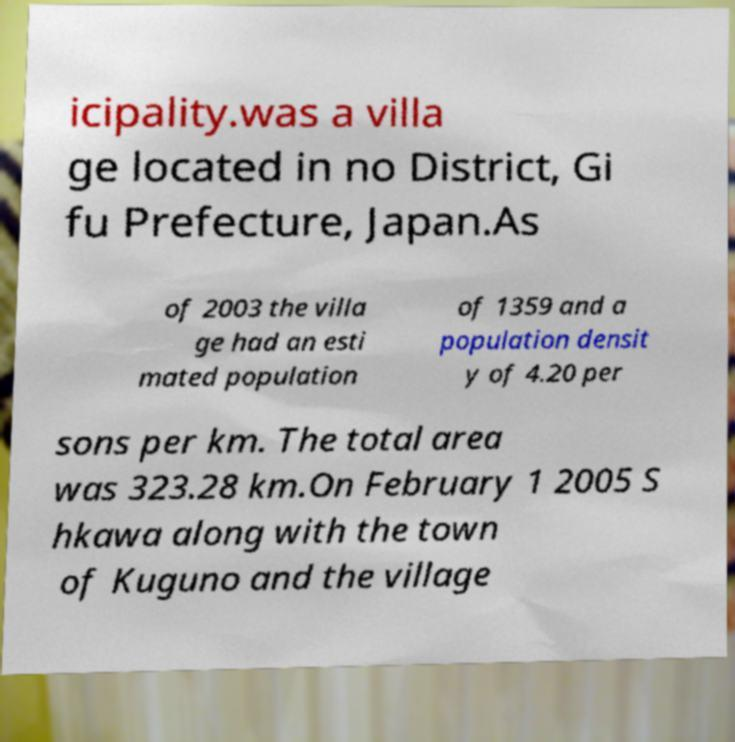Could you assist in decoding the text presented in this image and type it out clearly? icipality.was a villa ge located in no District, Gi fu Prefecture, Japan.As of 2003 the villa ge had an esti mated population of 1359 and a population densit y of 4.20 per sons per km. The total area was 323.28 km.On February 1 2005 S hkawa along with the town of Kuguno and the village 